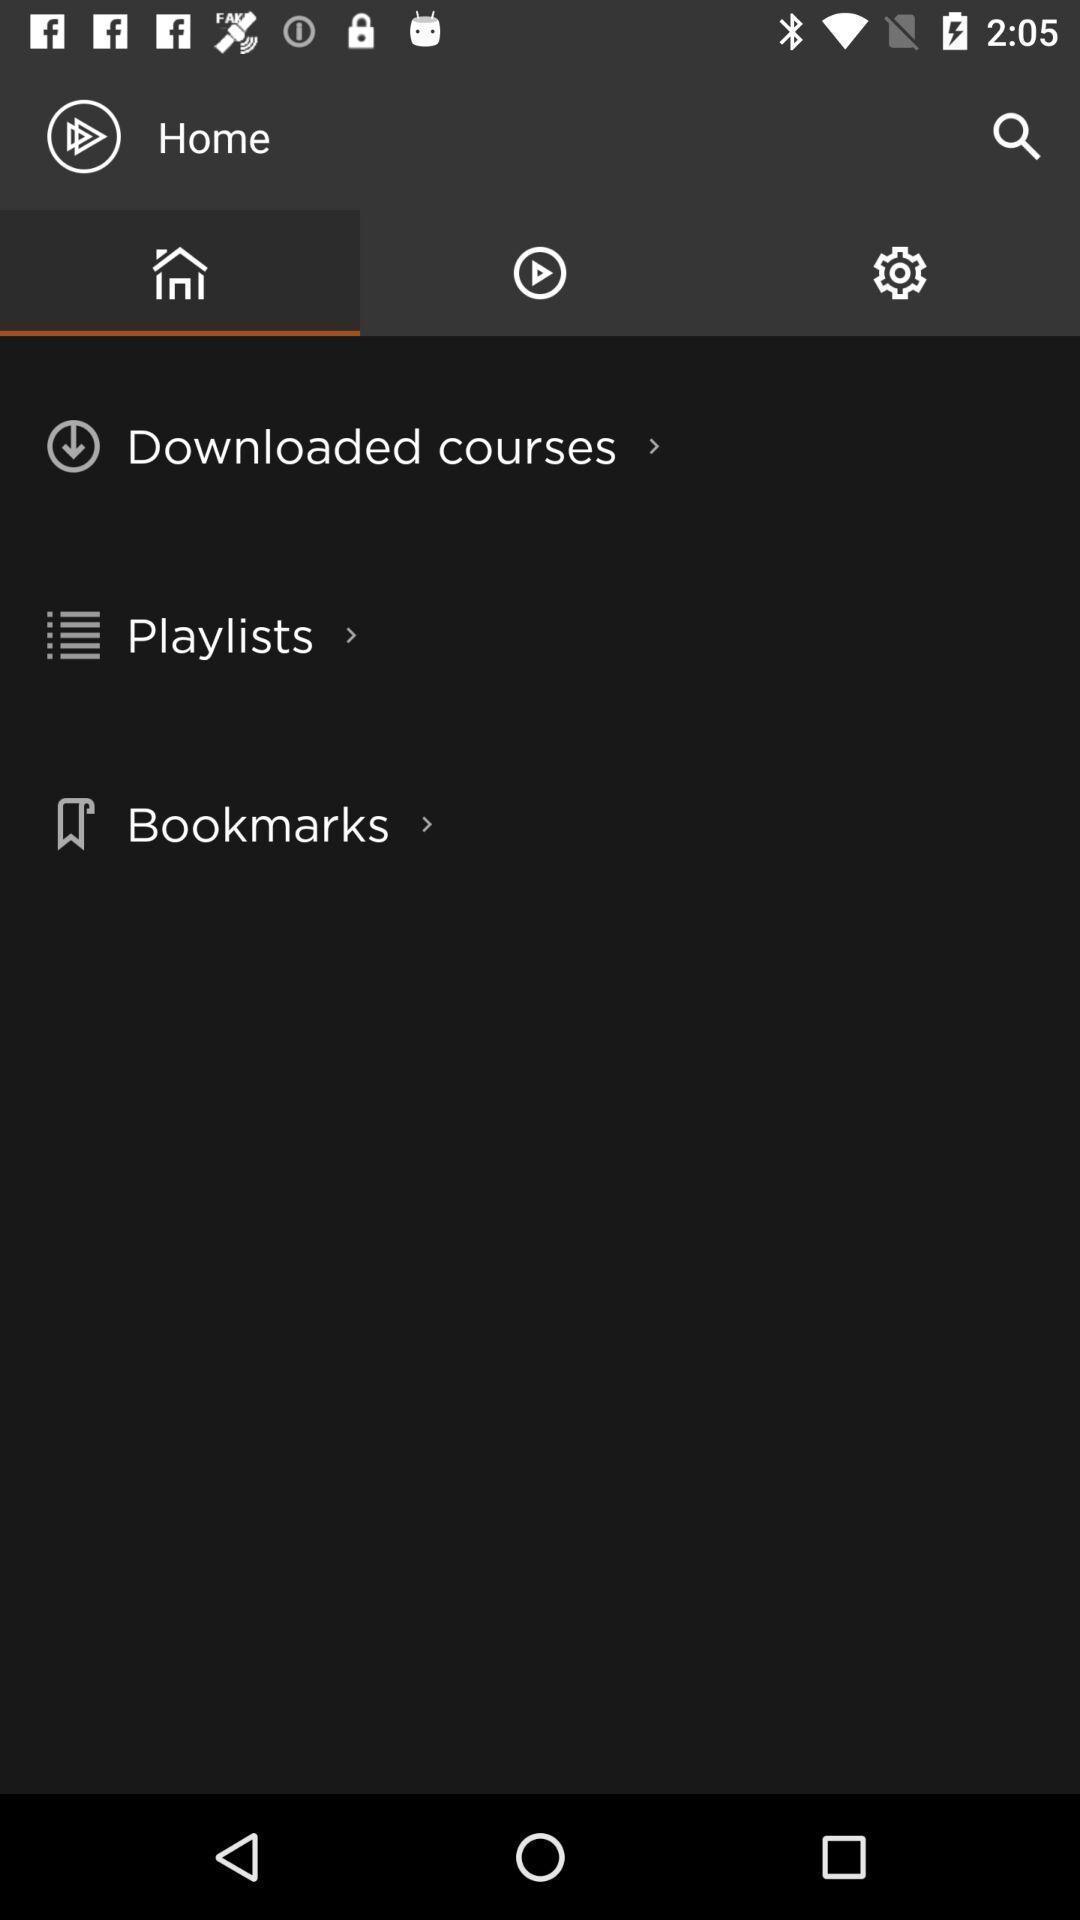Give me a narrative description of this picture. Screen displaying the home page. 